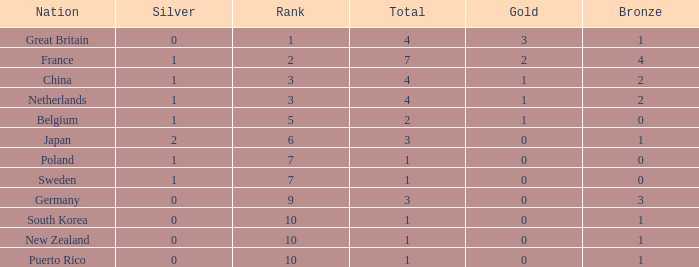What is the total where the gold is larger than 2? 1.0. 